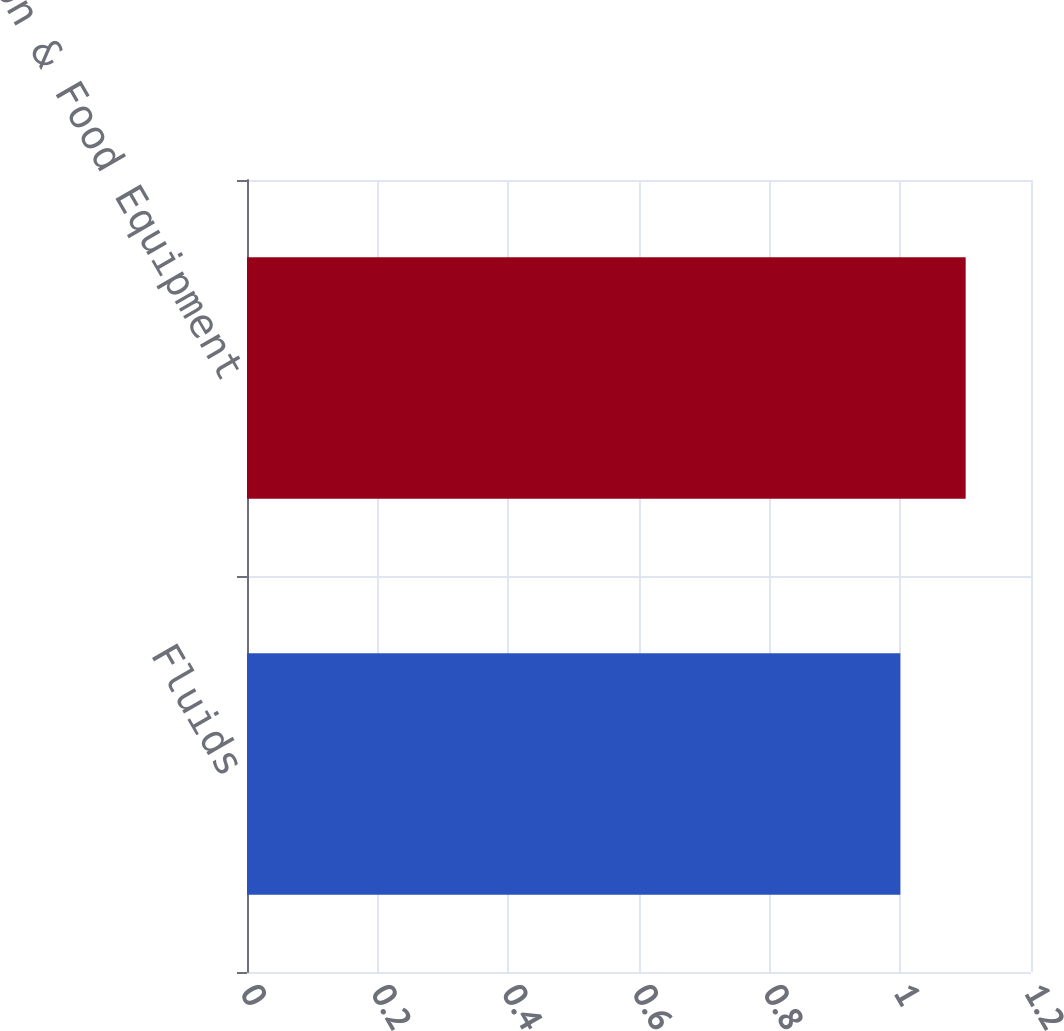Convert chart to OTSL. <chart><loc_0><loc_0><loc_500><loc_500><bar_chart><fcel>Fluids<fcel>Refrigeration & Food Equipment<nl><fcel>1<fcel>1.1<nl></chart> 